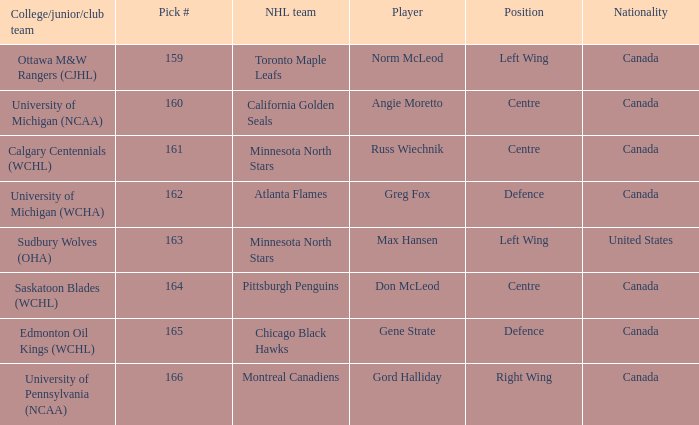Could you help me parse every detail presented in this table? {'header': ['College/junior/club team', 'Pick #', 'NHL team', 'Player', 'Position', 'Nationality'], 'rows': [['Ottawa M&W Rangers (CJHL)', '159', 'Toronto Maple Leafs', 'Norm McLeod', 'Left Wing', 'Canada'], ['University of Michigan (NCAA)', '160', 'California Golden Seals', 'Angie Moretto', 'Centre', 'Canada'], ['Calgary Centennials (WCHL)', '161', 'Minnesota North Stars', 'Russ Wiechnik', 'Centre', 'Canada'], ['University of Michigan (WCHA)', '162', 'Atlanta Flames', 'Greg Fox', 'Defence', 'Canada'], ['Sudbury Wolves (OHA)', '163', 'Minnesota North Stars', 'Max Hansen', 'Left Wing', 'United States'], ['Saskatoon Blades (WCHL)', '164', 'Pittsburgh Penguins', 'Don McLeod', 'Centre', 'Canada'], ['Edmonton Oil Kings (WCHL)', '165', 'Chicago Black Hawks', 'Gene Strate', 'Defence', 'Canada'], ['University of Pennsylvania (NCAA)', '166', 'Montreal Canadiens', 'Gord Halliday', 'Right Wing', 'Canada']]} How many players have the pick number 166? 1.0. 